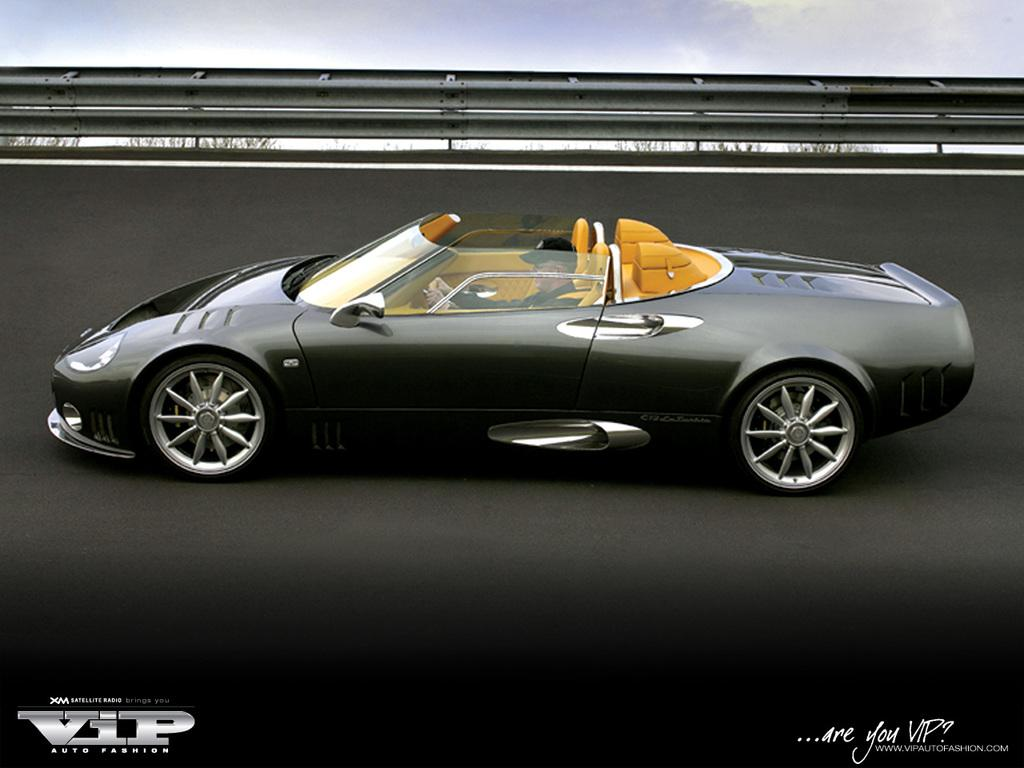Who is present in the image? There is a person in the image. What is the person doing in the image? The person is sitting in a car. What color is the car in the image? The car is black. What type of head is the person wearing in the image? There is no mention of any head or apparel in the image, so it cannot be determined if the person is wearing any specific type of head. 